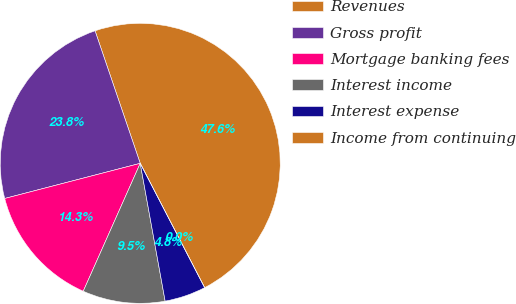Convert chart to OTSL. <chart><loc_0><loc_0><loc_500><loc_500><pie_chart><fcel>Revenues<fcel>Gross profit<fcel>Mortgage banking fees<fcel>Interest income<fcel>Interest expense<fcel>Income from continuing<nl><fcel>47.62%<fcel>23.81%<fcel>14.29%<fcel>9.52%<fcel>4.76%<fcel>0.0%<nl></chart> 